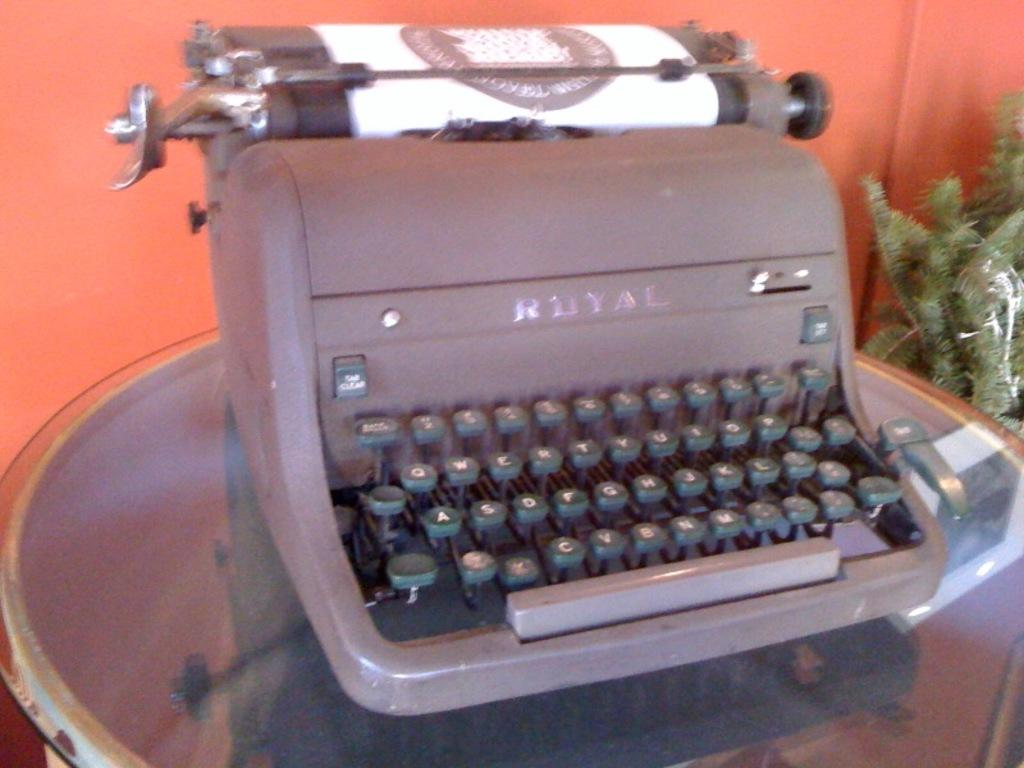<image>
Offer a succinct explanation of the picture presented. An old Royal typewriter that is sitting on a round table. 